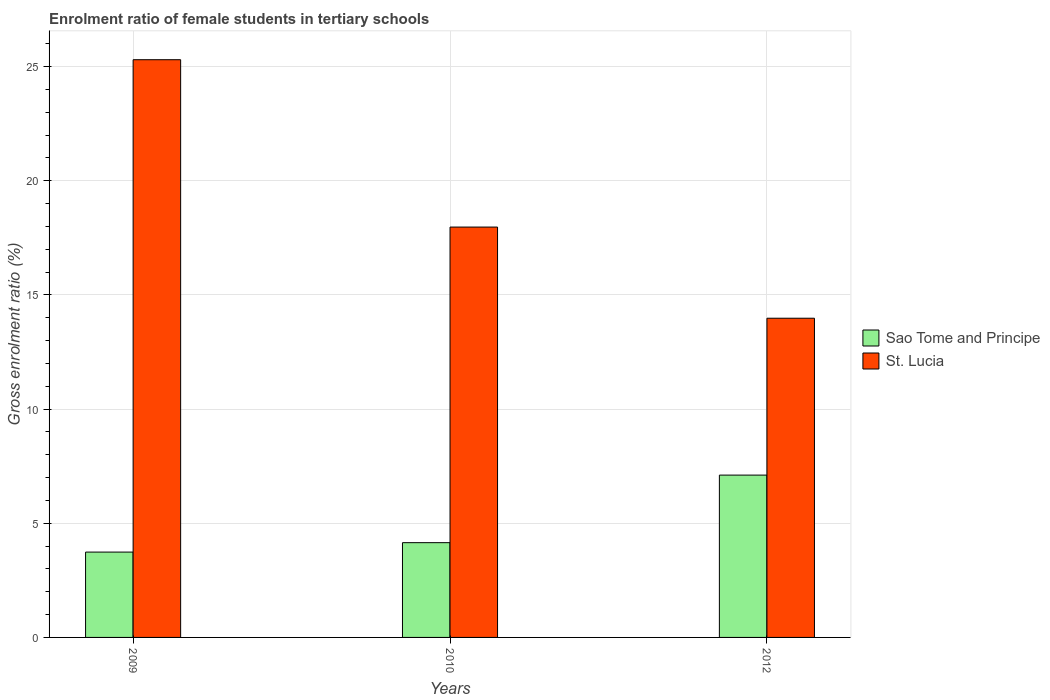How many different coloured bars are there?
Provide a short and direct response. 2. What is the enrolment ratio of female students in tertiary schools in St. Lucia in 2012?
Give a very brief answer. 13.98. Across all years, what is the maximum enrolment ratio of female students in tertiary schools in Sao Tome and Principe?
Your response must be concise. 7.11. Across all years, what is the minimum enrolment ratio of female students in tertiary schools in Sao Tome and Principe?
Your response must be concise. 3.74. What is the total enrolment ratio of female students in tertiary schools in Sao Tome and Principe in the graph?
Make the answer very short. 14.99. What is the difference between the enrolment ratio of female students in tertiary schools in St. Lucia in 2009 and that in 2010?
Offer a very short reply. 7.33. What is the difference between the enrolment ratio of female students in tertiary schools in Sao Tome and Principe in 2010 and the enrolment ratio of female students in tertiary schools in St. Lucia in 2012?
Offer a very short reply. -9.83. What is the average enrolment ratio of female students in tertiary schools in St. Lucia per year?
Provide a succinct answer. 19.08. In the year 2012, what is the difference between the enrolment ratio of female students in tertiary schools in St. Lucia and enrolment ratio of female students in tertiary schools in Sao Tome and Principe?
Provide a short and direct response. 6.87. What is the ratio of the enrolment ratio of female students in tertiary schools in Sao Tome and Principe in 2009 to that in 2012?
Give a very brief answer. 0.53. Is the enrolment ratio of female students in tertiary schools in Sao Tome and Principe in 2009 less than that in 2010?
Make the answer very short. Yes. Is the difference between the enrolment ratio of female students in tertiary schools in St. Lucia in 2009 and 2012 greater than the difference between the enrolment ratio of female students in tertiary schools in Sao Tome and Principe in 2009 and 2012?
Give a very brief answer. Yes. What is the difference between the highest and the second highest enrolment ratio of female students in tertiary schools in St. Lucia?
Keep it short and to the point. 7.33. What is the difference between the highest and the lowest enrolment ratio of female students in tertiary schools in St. Lucia?
Give a very brief answer. 11.32. Is the sum of the enrolment ratio of female students in tertiary schools in St. Lucia in 2010 and 2012 greater than the maximum enrolment ratio of female students in tertiary schools in Sao Tome and Principe across all years?
Keep it short and to the point. Yes. What does the 1st bar from the left in 2009 represents?
Provide a short and direct response. Sao Tome and Principe. What does the 1st bar from the right in 2012 represents?
Offer a terse response. St. Lucia. How many bars are there?
Keep it short and to the point. 6. Does the graph contain any zero values?
Ensure brevity in your answer.  No. Where does the legend appear in the graph?
Your response must be concise. Center right. How many legend labels are there?
Ensure brevity in your answer.  2. How are the legend labels stacked?
Offer a very short reply. Vertical. What is the title of the graph?
Provide a short and direct response. Enrolment ratio of female students in tertiary schools. What is the label or title of the X-axis?
Ensure brevity in your answer.  Years. What is the label or title of the Y-axis?
Your answer should be very brief. Gross enrolment ratio (%). What is the Gross enrolment ratio (%) in Sao Tome and Principe in 2009?
Offer a terse response. 3.74. What is the Gross enrolment ratio (%) of St. Lucia in 2009?
Your answer should be compact. 25.3. What is the Gross enrolment ratio (%) of Sao Tome and Principe in 2010?
Ensure brevity in your answer.  4.15. What is the Gross enrolment ratio (%) in St. Lucia in 2010?
Keep it short and to the point. 17.97. What is the Gross enrolment ratio (%) of Sao Tome and Principe in 2012?
Ensure brevity in your answer.  7.11. What is the Gross enrolment ratio (%) of St. Lucia in 2012?
Provide a succinct answer. 13.98. Across all years, what is the maximum Gross enrolment ratio (%) of Sao Tome and Principe?
Ensure brevity in your answer.  7.11. Across all years, what is the maximum Gross enrolment ratio (%) of St. Lucia?
Provide a short and direct response. 25.3. Across all years, what is the minimum Gross enrolment ratio (%) in Sao Tome and Principe?
Ensure brevity in your answer.  3.74. Across all years, what is the minimum Gross enrolment ratio (%) in St. Lucia?
Your answer should be compact. 13.98. What is the total Gross enrolment ratio (%) in Sao Tome and Principe in the graph?
Ensure brevity in your answer.  14.99. What is the total Gross enrolment ratio (%) of St. Lucia in the graph?
Offer a very short reply. 57.24. What is the difference between the Gross enrolment ratio (%) of Sao Tome and Principe in 2009 and that in 2010?
Provide a succinct answer. -0.41. What is the difference between the Gross enrolment ratio (%) of St. Lucia in 2009 and that in 2010?
Your answer should be very brief. 7.33. What is the difference between the Gross enrolment ratio (%) in Sao Tome and Principe in 2009 and that in 2012?
Offer a terse response. -3.37. What is the difference between the Gross enrolment ratio (%) of St. Lucia in 2009 and that in 2012?
Give a very brief answer. 11.32. What is the difference between the Gross enrolment ratio (%) in Sao Tome and Principe in 2010 and that in 2012?
Ensure brevity in your answer.  -2.96. What is the difference between the Gross enrolment ratio (%) in St. Lucia in 2010 and that in 2012?
Your answer should be compact. 3.99. What is the difference between the Gross enrolment ratio (%) in Sao Tome and Principe in 2009 and the Gross enrolment ratio (%) in St. Lucia in 2010?
Your answer should be very brief. -14.23. What is the difference between the Gross enrolment ratio (%) in Sao Tome and Principe in 2009 and the Gross enrolment ratio (%) in St. Lucia in 2012?
Make the answer very short. -10.24. What is the difference between the Gross enrolment ratio (%) in Sao Tome and Principe in 2010 and the Gross enrolment ratio (%) in St. Lucia in 2012?
Your answer should be compact. -9.83. What is the average Gross enrolment ratio (%) of Sao Tome and Principe per year?
Ensure brevity in your answer.  5. What is the average Gross enrolment ratio (%) in St. Lucia per year?
Offer a very short reply. 19.08. In the year 2009, what is the difference between the Gross enrolment ratio (%) in Sao Tome and Principe and Gross enrolment ratio (%) in St. Lucia?
Your answer should be very brief. -21.56. In the year 2010, what is the difference between the Gross enrolment ratio (%) in Sao Tome and Principe and Gross enrolment ratio (%) in St. Lucia?
Ensure brevity in your answer.  -13.82. In the year 2012, what is the difference between the Gross enrolment ratio (%) of Sao Tome and Principe and Gross enrolment ratio (%) of St. Lucia?
Provide a short and direct response. -6.87. What is the ratio of the Gross enrolment ratio (%) in Sao Tome and Principe in 2009 to that in 2010?
Provide a short and direct response. 0.9. What is the ratio of the Gross enrolment ratio (%) of St. Lucia in 2009 to that in 2010?
Ensure brevity in your answer.  1.41. What is the ratio of the Gross enrolment ratio (%) of Sao Tome and Principe in 2009 to that in 2012?
Your answer should be very brief. 0.53. What is the ratio of the Gross enrolment ratio (%) in St. Lucia in 2009 to that in 2012?
Your answer should be very brief. 1.81. What is the ratio of the Gross enrolment ratio (%) of Sao Tome and Principe in 2010 to that in 2012?
Your response must be concise. 0.58. What is the ratio of the Gross enrolment ratio (%) in St. Lucia in 2010 to that in 2012?
Offer a terse response. 1.29. What is the difference between the highest and the second highest Gross enrolment ratio (%) in Sao Tome and Principe?
Keep it short and to the point. 2.96. What is the difference between the highest and the second highest Gross enrolment ratio (%) of St. Lucia?
Ensure brevity in your answer.  7.33. What is the difference between the highest and the lowest Gross enrolment ratio (%) in Sao Tome and Principe?
Your response must be concise. 3.37. What is the difference between the highest and the lowest Gross enrolment ratio (%) of St. Lucia?
Ensure brevity in your answer.  11.32. 